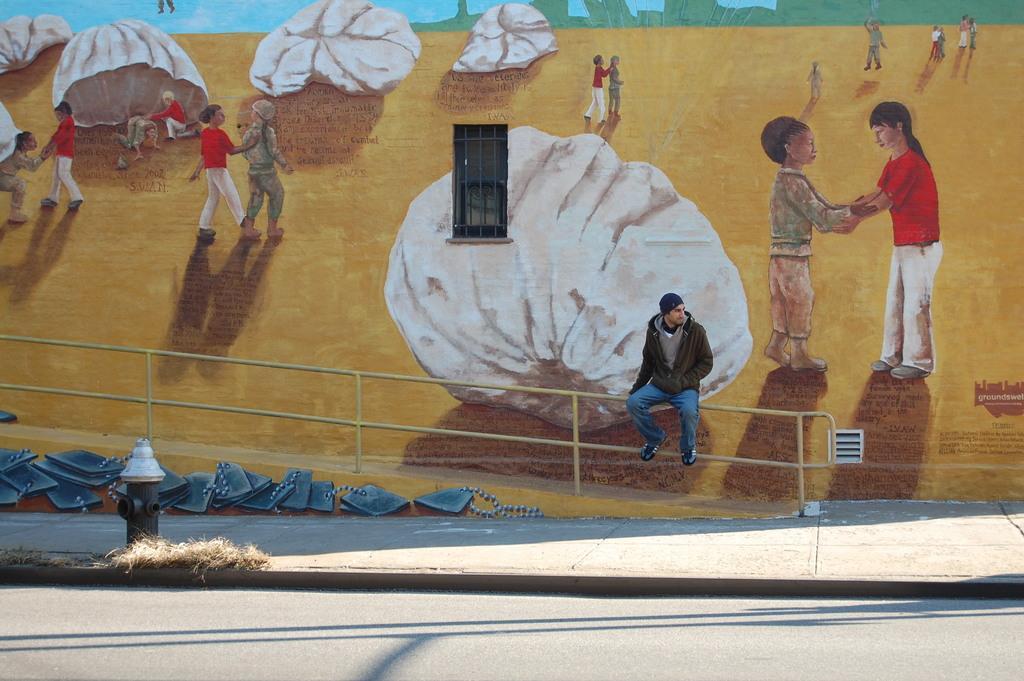Could you give a brief overview of what you see in this image? This picture is clicked outside the city. At the bottom of the picture, we see the road and a pole. Behind that, there are blue color things placed on the road. Behind that, the man in a green jacket is sitting on the iron rod and we see a ramp. In the background, we see a wall painting. 